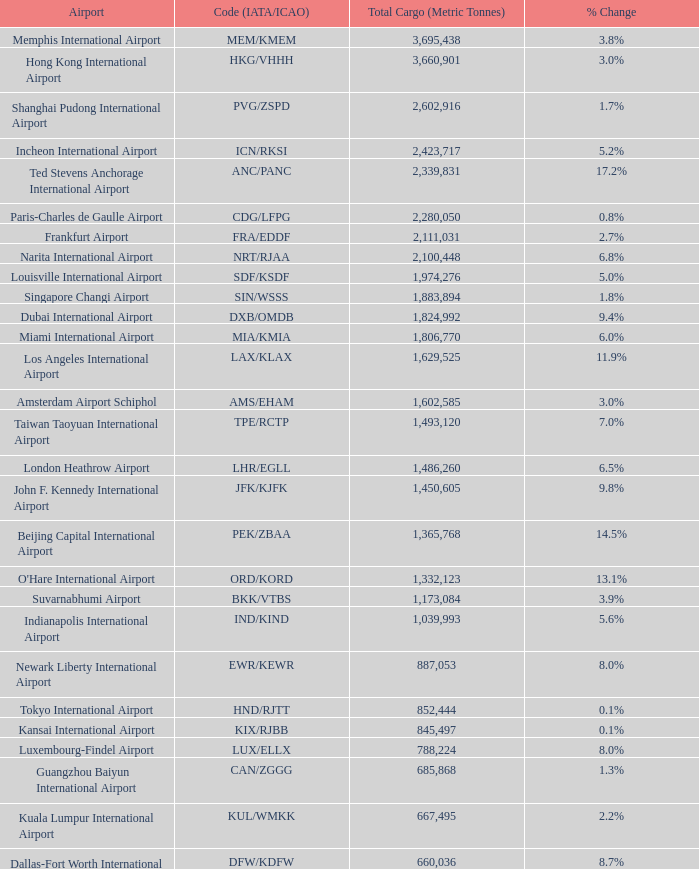What is the code for rank 10? SIN/WSSS. 